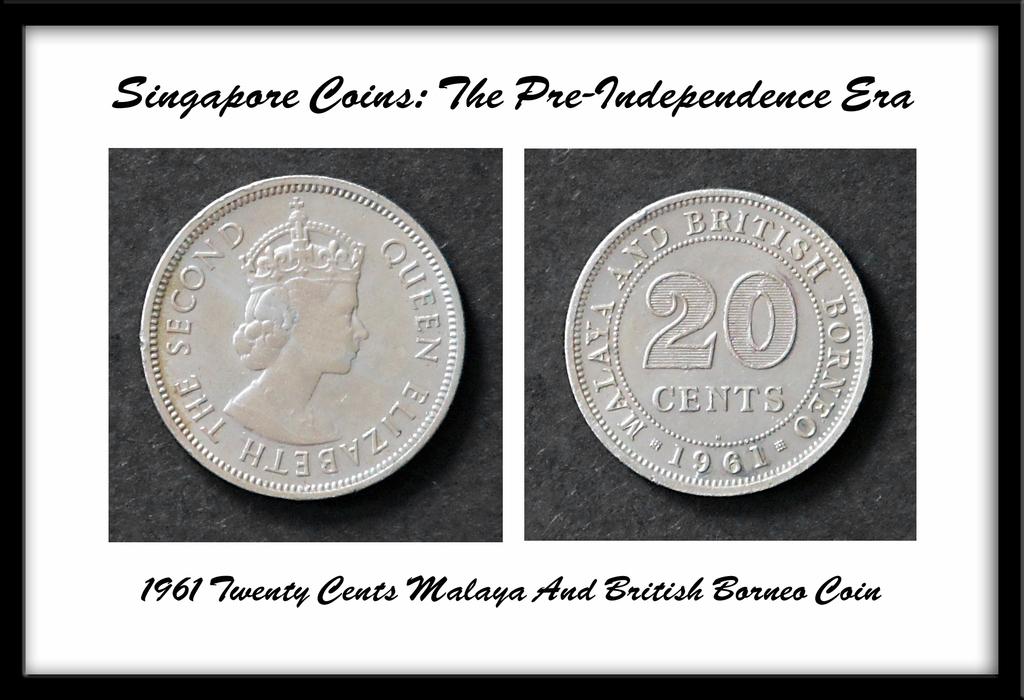How many cents is this coin worth?
Offer a very short reply. 20. What year was this coin made?
Ensure brevity in your answer.  1961. 